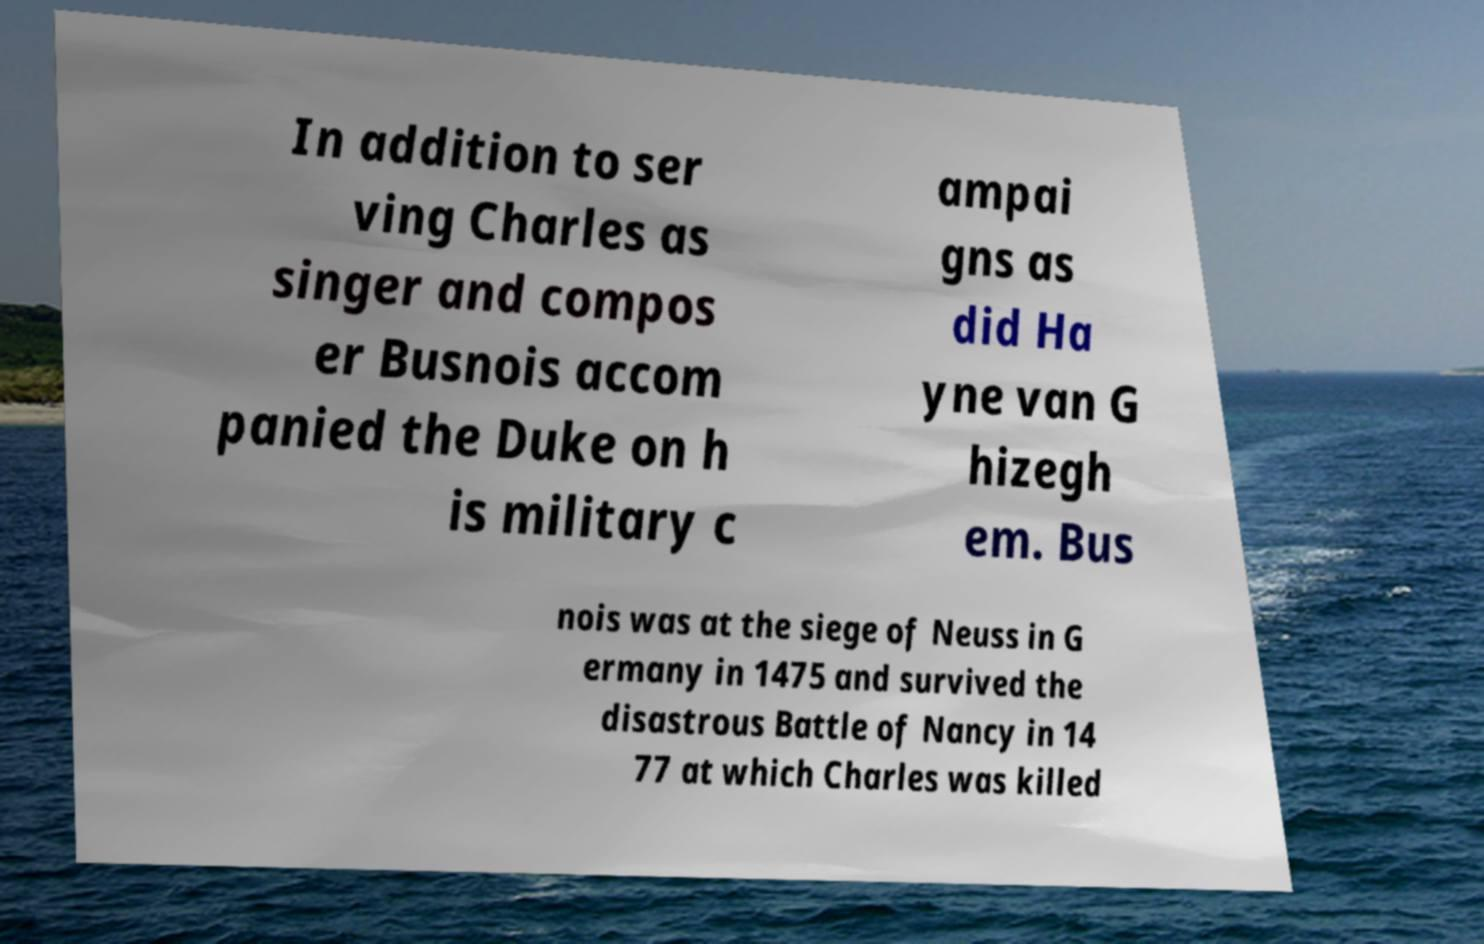Please read and relay the text visible in this image. What does it say? In addition to ser ving Charles as singer and compos er Busnois accom panied the Duke on h is military c ampai gns as did Ha yne van G hizegh em. Bus nois was at the siege of Neuss in G ermany in 1475 and survived the disastrous Battle of Nancy in 14 77 at which Charles was killed 